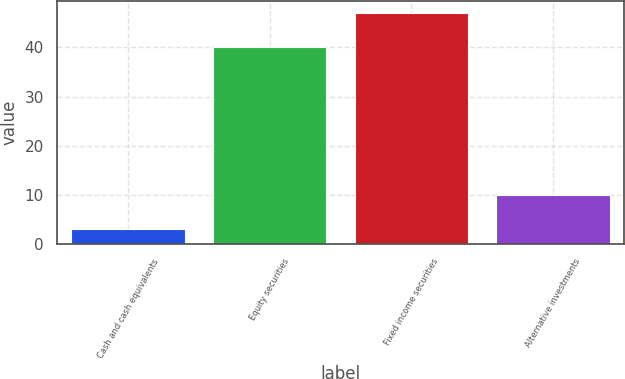Convert chart to OTSL. <chart><loc_0><loc_0><loc_500><loc_500><bar_chart><fcel>Cash and cash equivalents<fcel>Equity securities<fcel>Fixed income securities<fcel>Alternative investments<nl><fcel>3<fcel>40<fcel>47<fcel>10<nl></chart> 